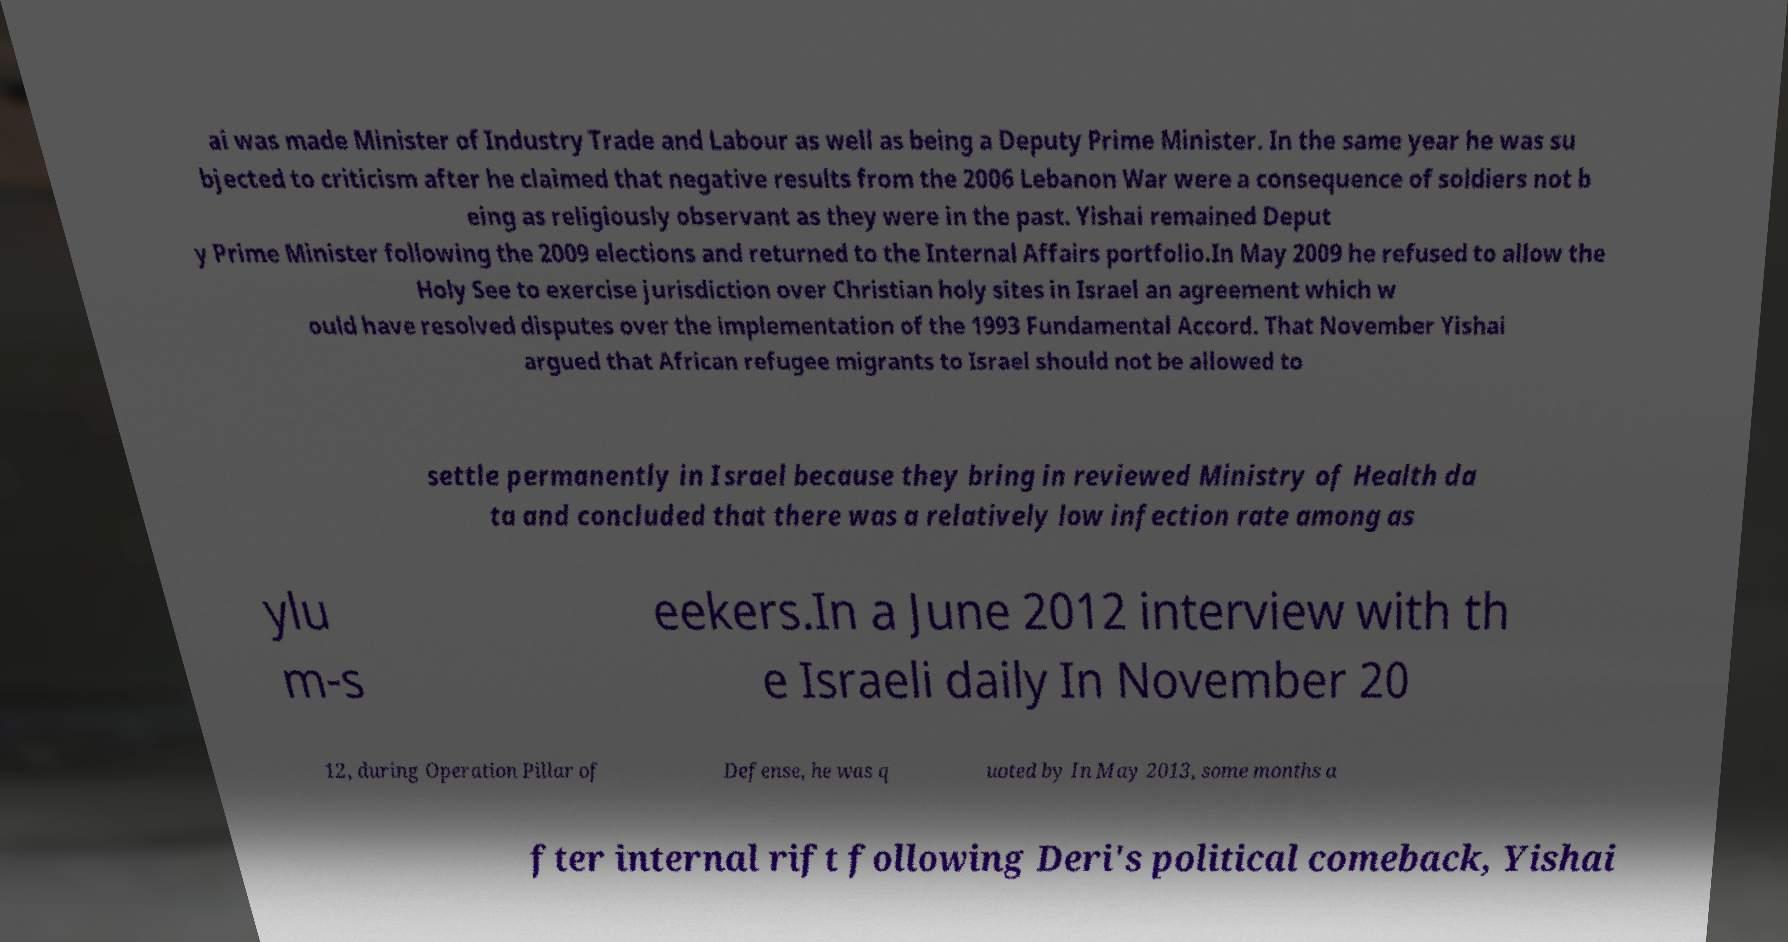Please identify and transcribe the text found in this image. ai was made Minister of Industry Trade and Labour as well as being a Deputy Prime Minister. In the same year he was su bjected to criticism after he claimed that negative results from the 2006 Lebanon War were a consequence of soldiers not b eing as religiously observant as they were in the past. Yishai remained Deput y Prime Minister following the 2009 elections and returned to the Internal Affairs portfolio.In May 2009 he refused to allow the Holy See to exercise jurisdiction over Christian holy sites in Israel an agreement which w ould have resolved disputes over the implementation of the 1993 Fundamental Accord. That November Yishai argued that African refugee migrants to Israel should not be allowed to settle permanently in Israel because they bring in reviewed Ministry of Health da ta and concluded that there was a relatively low infection rate among as ylu m-s eekers.In a June 2012 interview with th e Israeli daily In November 20 12, during Operation Pillar of Defense, he was q uoted by In May 2013, some months a fter internal rift following Deri's political comeback, Yishai 